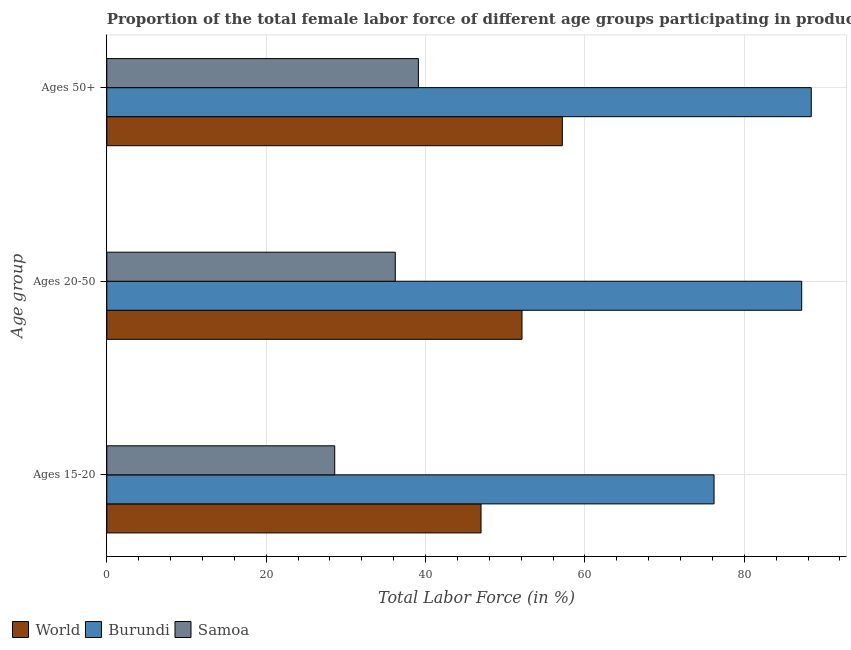How many groups of bars are there?
Offer a very short reply. 3. Are the number of bars per tick equal to the number of legend labels?
Make the answer very short. Yes. Are the number of bars on each tick of the Y-axis equal?
Make the answer very short. Yes. What is the label of the 3rd group of bars from the top?
Offer a terse response. Ages 15-20. What is the percentage of female labor force above age 50 in World?
Ensure brevity in your answer.  57.16. Across all countries, what is the maximum percentage of female labor force within the age group 15-20?
Offer a very short reply. 76.2. Across all countries, what is the minimum percentage of female labor force within the age group 20-50?
Give a very brief answer. 36.2. In which country was the percentage of female labor force within the age group 20-50 maximum?
Offer a terse response. Burundi. In which country was the percentage of female labor force within the age group 15-20 minimum?
Your answer should be compact. Samoa. What is the total percentage of female labor force within the age group 20-50 in the graph?
Provide a succinct answer. 175.5. What is the difference between the percentage of female labor force above age 50 in Burundi and that in Samoa?
Your answer should be compact. 49.3. What is the difference between the percentage of female labor force within the age group 15-20 in Burundi and the percentage of female labor force within the age group 20-50 in Samoa?
Give a very brief answer. 40. What is the average percentage of female labor force within the age group 20-50 per country?
Make the answer very short. 58.5. What is the difference between the percentage of female labor force within the age group 15-20 and percentage of female labor force above age 50 in World?
Your answer should be very brief. -10.2. In how many countries, is the percentage of female labor force within the age group 20-50 greater than 52 %?
Ensure brevity in your answer.  2. What is the ratio of the percentage of female labor force above age 50 in Samoa to that in World?
Offer a terse response. 0.68. Is the percentage of female labor force within the age group 15-20 in Burundi less than that in Samoa?
Make the answer very short. No. What is the difference between the highest and the second highest percentage of female labor force within the age group 20-50?
Your response must be concise. 35.1. What is the difference between the highest and the lowest percentage of female labor force above age 50?
Your response must be concise. 49.3. Is the sum of the percentage of female labor force within the age group 15-20 in Samoa and World greater than the maximum percentage of female labor force within the age group 20-50 across all countries?
Provide a short and direct response. No. What does the 2nd bar from the top in Ages 50+ represents?
Your answer should be compact. Burundi. What does the 2nd bar from the bottom in Ages 15-20 represents?
Provide a short and direct response. Burundi. How many bars are there?
Give a very brief answer. 9. Are all the bars in the graph horizontal?
Your answer should be very brief. Yes. How many countries are there in the graph?
Ensure brevity in your answer.  3. Are the values on the major ticks of X-axis written in scientific E-notation?
Offer a terse response. No. How are the legend labels stacked?
Provide a succinct answer. Horizontal. What is the title of the graph?
Offer a terse response. Proportion of the total female labor force of different age groups participating in production in 1996. What is the label or title of the Y-axis?
Provide a short and direct response. Age group. What is the Total Labor Force (in %) of World in Ages 15-20?
Your answer should be compact. 46.96. What is the Total Labor Force (in %) of Burundi in Ages 15-20?
Offer a very short reply. 76.2. What is the Total Labor Force (in %) in Samoa in Ages 15-20?
Offer a terse response. 28.6. What is the Total Labor Force (in %) in World in Ages 20-50?
Ensure brevity in your answer.  52.1. What is the Total Labor Force (in %) in Burundi in Ages 20-50?
Keep it short and to the point. 87.2. What is the Total Labor Force (in %) in Samoa in Ages 20-50?
Offer a terse response. 36.2. What is the Total Labor Force (in %) of World in Ages 50+?
Keep it short and to the point. 57.16. What is the Total Labor Force (in %) in Burundi in Ages 50+?
Offer a very short reply. 88.4. What is the Total Labor Force (in %) of Samoa in Ages 50+?
Offer a terse response. 39.1. Across all Age group, what is the maximum Total Labor Force (in %) of World?
Provide a succinct answer. 57.16. Across all Age group, what is the maximum Total Labor Force (in %) in Burundi?
Offer a terse response. 88.4. Across all Age group, what is the maximum Total Labor Force (in %) of Samoa?
Your response must be concise. 39.1. Across all Age group, what is the minimum Total Labor Force (in %) in World?
Ensure brevity in your answer.  46.96. Across all Age group, what is the minimum Total Labor Force (in %) in Burundi?
Give a very brief answer. 76.2. Across all Age group, what is the minimum Total Labor Force (in %) in Samoa?
Offer a terse response. 28.6. What is the total Total Labor Force (in %) in World in the graph?
Provide a succinct answer. 156.23. What is the total Total Labor Force (in %) in Burundi in the graph?
Provide a short and direct response. 251.8. What is the total Total Labor Force (in %) of Samoa in the graph?
Your answer should be compact. 103.9. What is the difference between the Total Labor Force (in %) in World in Ages 15-20 and that in Ages 20-50?
Provide a short and direct response. -5.14. What is the difference between the Total Labor Force (in %) in Burundi in Ages 15-20 and that in Ages 20-50?
Your answer should be very brief. -11. What is the difference between the Total Labor Force (in %) of Samoa in Ages 15-20 and that in Ages 20-50?
Ensure brevity in your answer.  -7.6. What is the difference between the Total Labor Force (in %) in World in Ages 15-20 and that in Ages 50+?
Your answer should be compact. -10.2. What is the difference between the Total Labor Force (in %) of Burundi in Ages 15-20 and that in Ages 50+?
Offer a terse response. -12.2. What is the difference between the Total Labor Force (in %) of Samoa in Ages 15-20 and that in Ages 50+?
Ensure brevity in your answer.  -10.5. What is the difference between the Total Labor Force (in %) of World in Ages 20-50 and that in Ages 50+?
Your answer should be compact. -5.06. What is the difference between the Total Labor Force (in %) in World in Ages 15-20 and the Total Labor Force (in %) in Burundi in Ages 20-50?
Make the answer very short. -40.24. What is the difference between the Total Labor Force (in %) in World in Ages 15-20 and the Total Labor Force (in %) in Samoa in Ages 20-50?
Give a very brief answer. 10.76. What is the difference between the Total Labor Force (in %) of Burundi in Ages 15-20 and the Total Labor Force (in %) of Samoa in Ages 20-50?
Offer a terse response. 40. What is the difference between the Total Labor Force (in %) of World in Ages 15-20 and the Total Labor Force (in %) of Burundi in Ages 50+?
Your response must be concise. -41.44. What is the difference between the Total Labor Force (in %) of World in Ages 15-20 and the Total Labor Force (in %) of Samoa in Ages 50+?
Your response must be concise. 7.86. What is the difference between the Total Labor Force (in %) of Burundi in Ages 15-20 and the Total Labor Force (in %) of Samoa in Ages 50+?
Make the answer very short. 37.1. What is the difference between the Total Labor Force (in %) in World in Ages 20-50 and the Total Labor Force (in %) in Burundi in Ages 50+?
Offer a very short reply. -36.3. What is the difference between the Total Labor Force (in %) in World in Ages 20-50 and the Total Labor Force (in %) in Samoa in Ages 50+?
Make the answer very short. 13. What is the difference between the Total Labor Force (in %) of Burundi in Ages 20-50 and the Total Labor Force (in %) of Samoa in Ages 50+?
Ensure brevity in your answer.  48.1. What is the average Total Labor Force (in %) of World per Age group?
Provide a short and direct response. 52.08. What is the average Total Labor Force (in %) of Burundi per Age group?
Your response must be concise. 83.93. What is the average Total Labor Force (in %) in Samoa per Age group?
Provide a succinct answer. 34.63. What is the difference between the Total Labor Force (in %) in World and Total Labor Force (in %) in Burundi in Ages 15-20?
Give a very brief answer. -29.24. What is the difference between the Total Labor Force (in %) of World and Total Labor Force (in %) of Samoa in Ages 15-20?
Make the answer very short. 18.36. What is the difference between the Total Labor Force (in %) in Burundi and Total Labor Force (in %) in Samoa in Ages 15-20?
Make the answer very short. 47.6. What is the difference between the Total Labor Force (in %) of World and Total Labor Force (in %) of Burundi in Ages 20-50?
Offer a terse response. -35.1. What is the difference between the Total Labor Force (in %) of World and Total Labor Force (in %) of Samoa in Ages 20-50?
Offer a very short reply. 15.9. What is the difference between the Total Labor Force (in %) of Burundi and Total Labor Force (in %) of Samoa in Ages 20-50?
Your answer should be compact. 51. What is the difference between the Total Labor Force (in %) of World and Total Labor Force (in %) of Burundi in Ages 50+?
Ensure brevity in your answer.  -31.24. What is the difference between the Total Labor Force (in %) in World and Total Labor Force (in %) in Samoa in Ages 50+?
Your answer should be very brief. 18.06. What is the difference between the Total Labor Force (in %) in Burundi and Total Labor Force (in %) in Samoa in Ages 50+?
Your response must be concise. 49.3. What is the ratio of the Total Labor Force (in %) of World in Ages 15-20 to that in Ages 20-50?
Ensure brevity in your answer.  0.9. What is the ratio of the Total Labor Force (in %) in Burundi in Ages 15-20 to that in Ages 20-50?
Make the answer very short. 0.87. What is the ratio of the Total Labor Force (in %) of Samoa in Ages 15-20 to that in Ages 20-50?
Your answer should be compact. 0.79. What is the ratio of the Total Labor Force (in %) in World in Ages 15-20 to that in Ages 50+?
Your answer should be very brief. 0.82. What is the ratio of the Total Labor Force (in %) of Burundi in Ages 15-20 to that in Ages 50+?
Offer a terse response. 0.86. What is the ratio of the Total Labor Force (in %) in Samoa in Ages 15-20 to that in Ages 50+?
Provide a succinct answer. 0.73. What is the ratio of the Total Labor Force (in %) in World in Ages 20-50 to that in Ages 50+?
Your response must be concise. 0.91. What is the ratio of the Total Labor Force (in %) in Burundi in Ages 20-50 to that in Ages 50+?
Your answer should be very brief. 0.99. What is the ratio of the Total Labor Force (in %) in Samoa in Ages 20-50 to that in Ages 50+?
Your answer should be compact. 0.93. What is the difference between the highest and the second highest Total Labor Force (in %) of World?
Give a very brief answer. 5.06. What is the difference between the highest and the second highest Total Labor Force (in %) in Samoa?
Keep it short and to the point. 2.9. What is the difference between the highest and the lowest Total Labor Force (in %) in World?
Your answer should be compact. 10.2. 